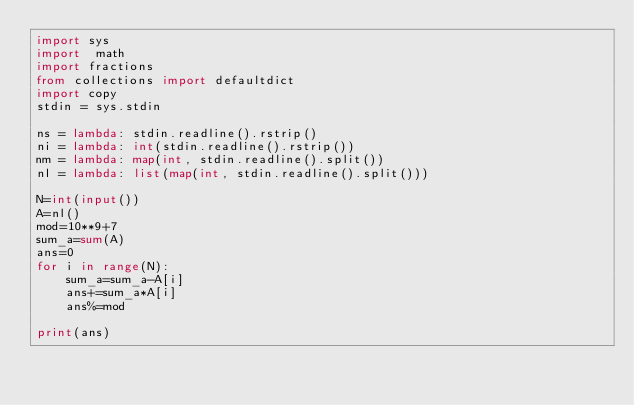Convert code to text. <code><loc_0><loc_0><loc_500><loc_500><_Python_>import sys
import  math
import fractions
from collections import defaultdict
import copy
stdin = sys.stdin
     
ns = lambda: stdin.readline().rstrip()
ni = lambda: int(stdin.readline().rstrip())
nm = lambda: map(int, stdin.readline().split())
nl = lambda: list(map(int, stdin.readline().split()))

N=int(input())
A=nl()
mod=10**9+7
sum_a=sum(A)
ans=0
for i in range(N):
    sum_a=sum_a-A[i]
    ans+=sum_a*A[i]
    ans%=mod

print(ans)


    </code> 